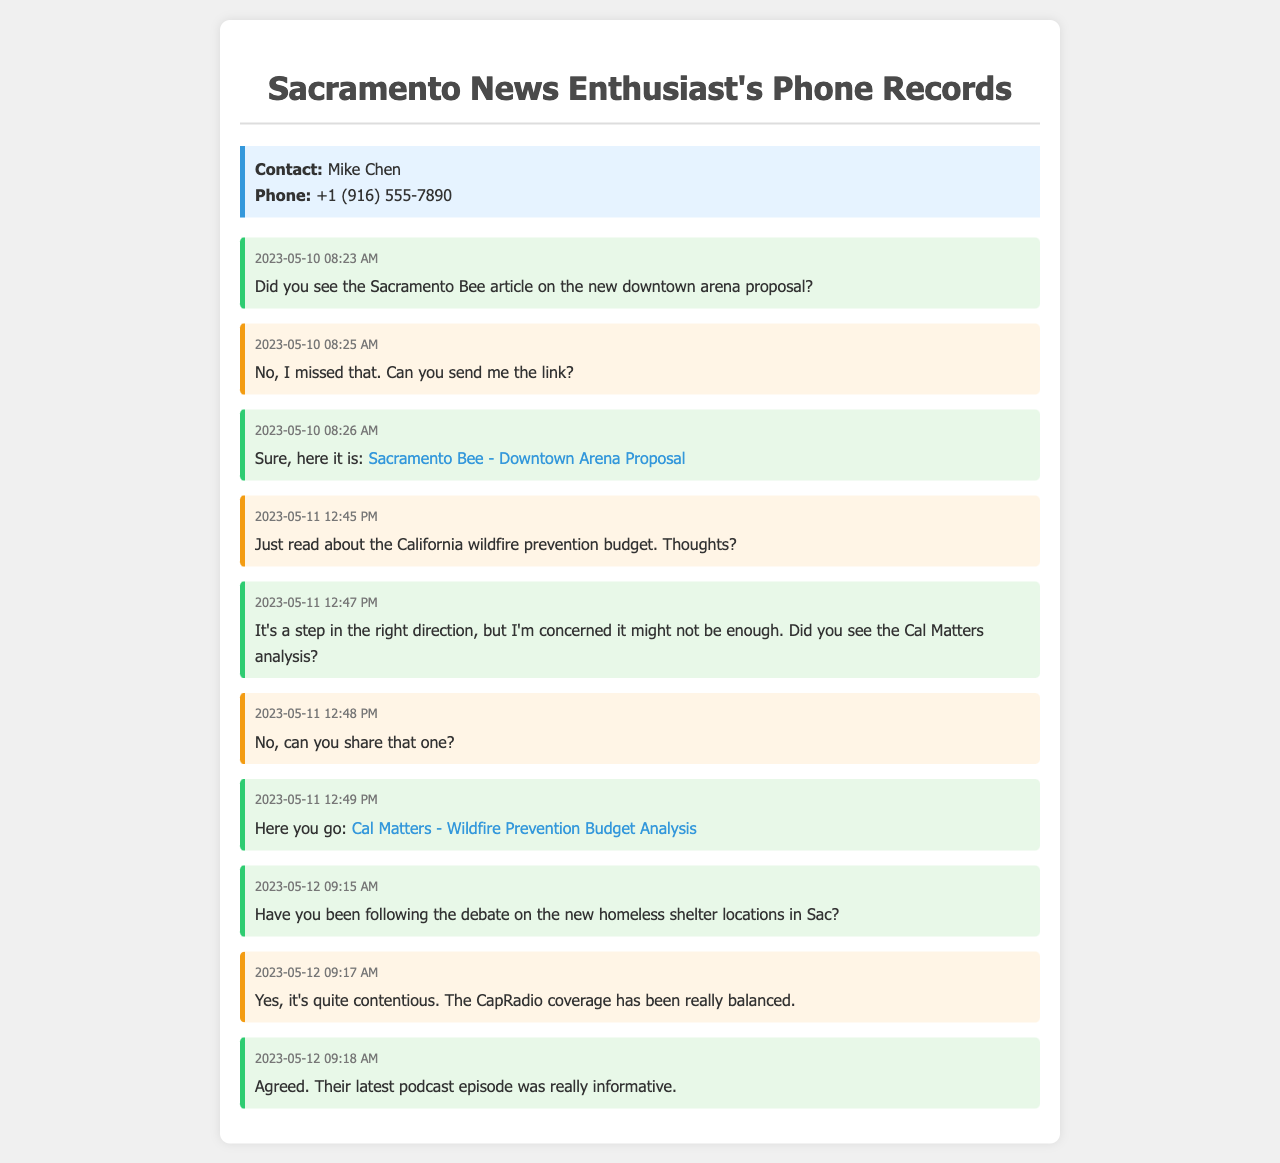What is the name of the contact? The contact's name is mentioned at the top of the document under contact information.
Answer: Mike Chen What is the phone number of the contact? The phone number is also provided in the contact information section of the document.
Answer: +1 (916) 555-7890 What is the date of the first message? The first date mentioned in the records is specified in the date-time section of the first message.
Answer: 2023-05-10 What article is mentioned regarding the downtown arena proposal? The article title is noted in the content of the third message exchanged between the two contacts.
Answer: Sacramento Bee - Downtown Arena Proposal What is the concern raised about the wildfire prevention budget? The concern is found within the context of the messages discussing the wildfire prevention budget and can be inferred from the explanation given.
Answer: Might not be enough How many messages were exchanged on May 12? To find the number of messages exchanged on May 12, the specific date mentioned in the date-time section of the messages must be counted.
Answer: 3 Did the contact share a podcast episode? This can be verified by looking at the discussions related to the homeless shelter debate to find the mention of the podcast.
Answer: Yes What website is linked for the wildfire prevention budget analysis? The specific URL is provided in one of the messages exchanged discussing the wildfire prevention budget.
Answer: calmatters.org What time was the last message sent? The time is recorded in the date-time section of the last message contained in the document.
Answer: 09:18 AM 